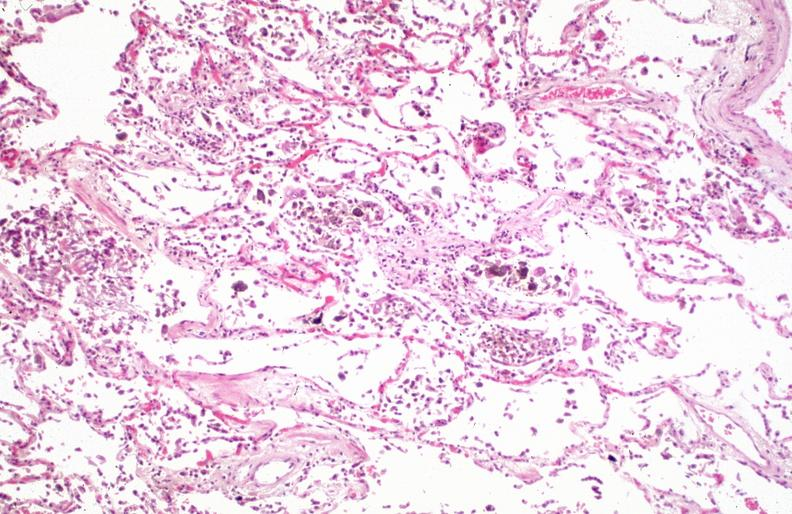what does this image show?
Answer the question using a single word or phrase. Lung 